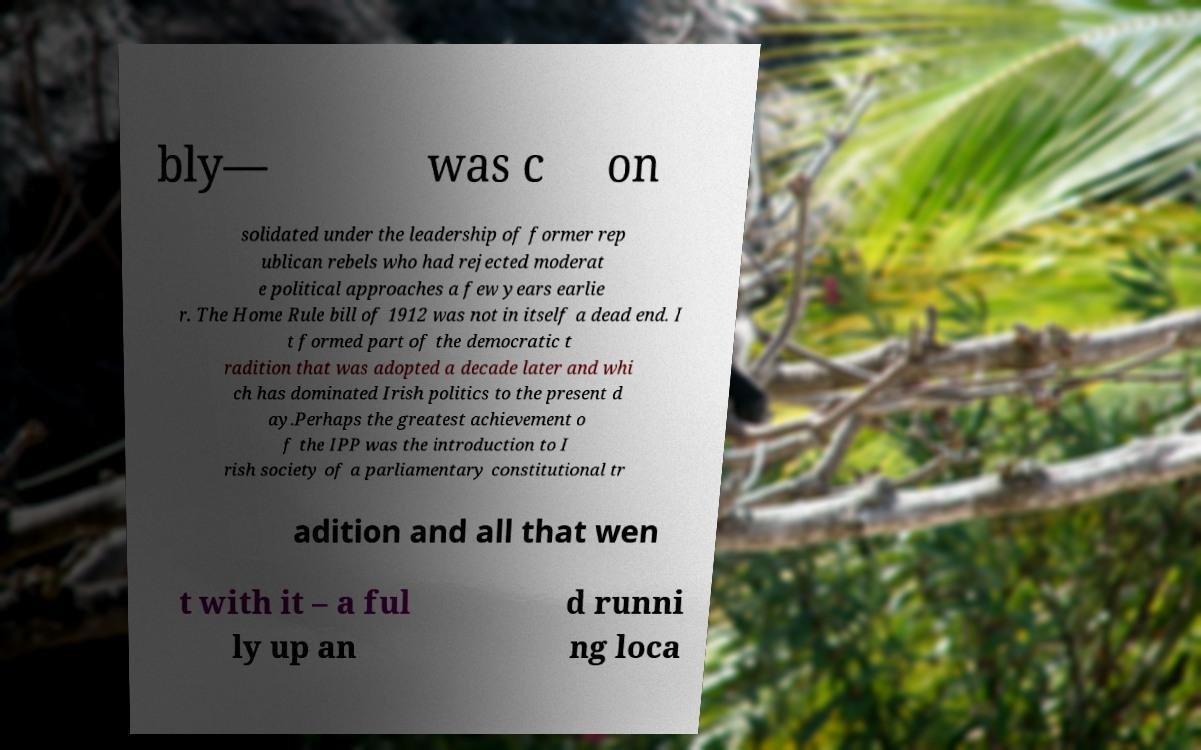Can you read and provide the text displayed in the image?This photo seems to have some interesting text. Can you extract and type it out for me? bly— was c on solidated under the leadership of former rep ublican rebels who had rejected moderat e political approaches a few years earlie r. The Home Rule bill of 1912 was not in itself a dead end. I t formed part of the democratic t radition that was adopted a decade later and whi ch has dominated Irish politics to the present d ay.Perhaps the greatest achievement o f the IPP was the introduction to I rish society of a parliamentary constitutional tr adition and all that wen t with it – a ful ly up an d runni ng loca 